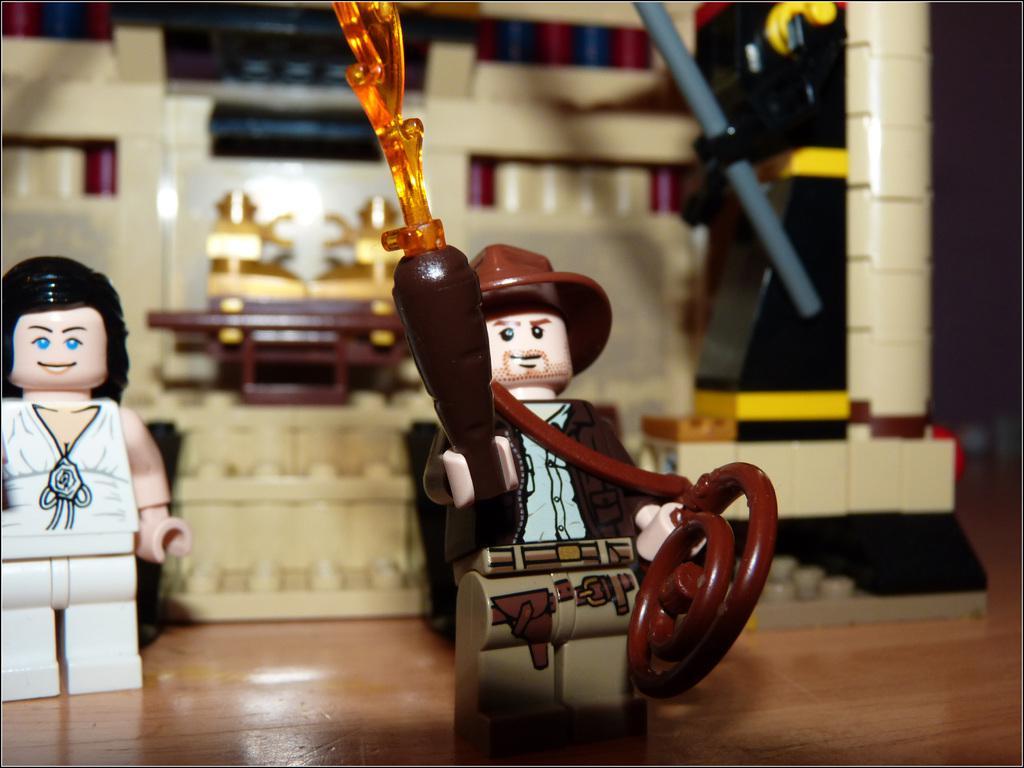Please provide a concise description of this image. In this picture we can see toys on a platform and in the background we can see some objects. 